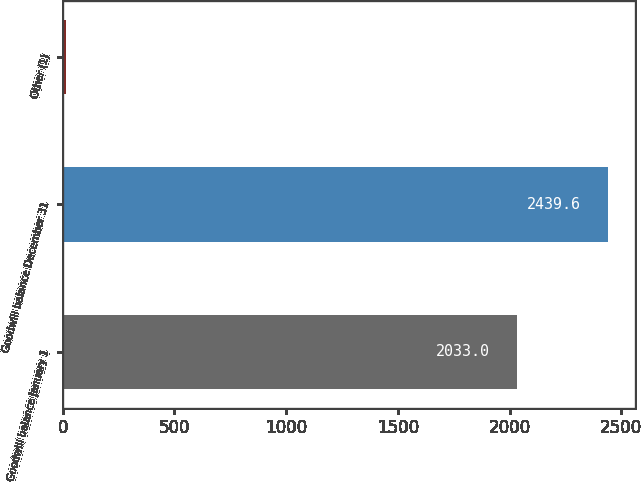Convert chart to OTSL. <chart><loc_0><loc_0><loc_500><loc_500><bar_chart><fcel>Goodwill balance January 1<fcel>Goodwill balance December 31<fcel>Other (1)<nl><fcel>2033<fcel>2439.6<fcel>15<nl></chart> 